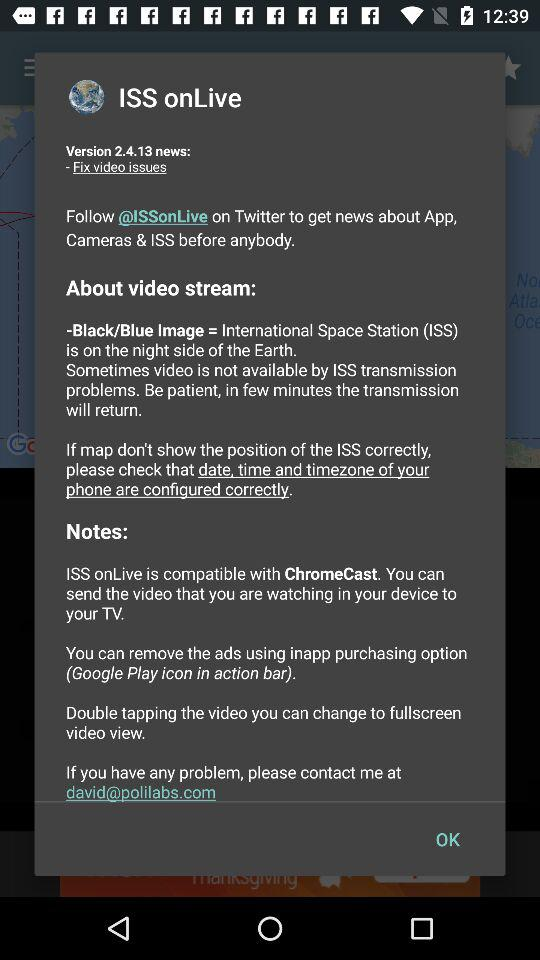What is the full form of the ISS? The full form of the ISS is the International Space Station. 